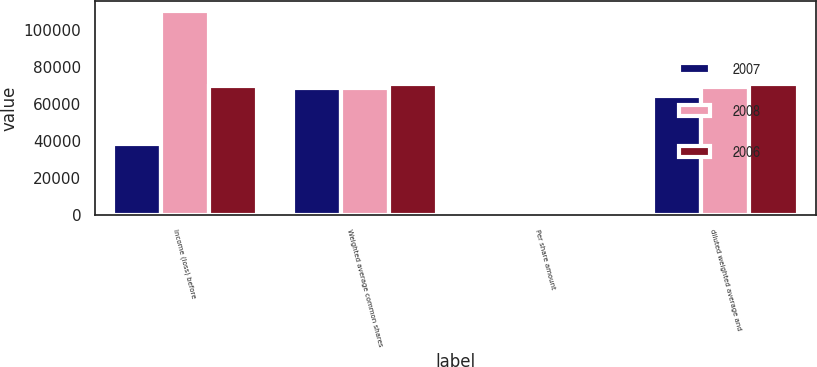Convert chart to OTSL. <chart><loc_0><loc_0><loc_500><loc_500><stacked_bar_chart><ecel><fcel>Income (loss) before<fcel>Weighted average common shares<fcel>Per share amount<fcel>diluted weighted average and<nl><fcel>2007<fcel>38421<fcel>68463<fcel>0.6<fcel>64524<nl><fcel>2008<fcel>110113<fcel>68463<fcel>1.61<fcel>68908<nl><fcel>2006<fcel>69627<fcel>70516<fcel>0.99<fcel>70956<nl></chart> 